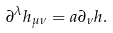Convert formula to latex. <formula><loc_0><loc_0><loc_500><loc_500>\partial ^ { \lambda } h _ { \mu \nu } = a \partial _ { \nu } h .</formula> 